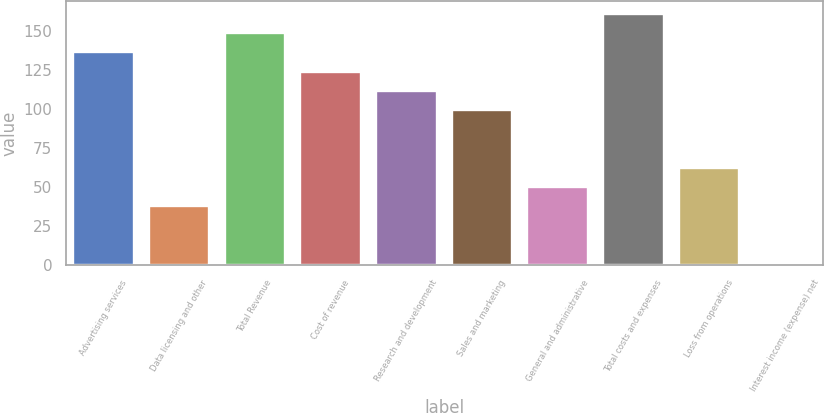Convert chart to OTSL. <chart><loc_0><loc_0><loc_500><loc_500><bar_chart><fcel>Advertising services<fcel>Data licensing and other<fcel>Total Revenue<fcel>Cost of revenue<fcel>Research and development<fcel>Sales and marketing<fcel>General and administrative<fcel>Total costs and expenses<fcel>Loss from operations<fcel>Interest income (expense) net<nl><fcel>136.3<fcel>37.9<fcel>148.6<fcel>124<fcel>111.7<fcel>99.4<fcel>50.2<fcel>160.9<fcel>62.5<fcel>1<nl></chart> 